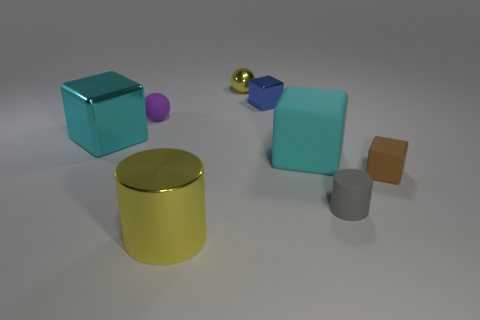Is there any other thing of the same color as the metallic cylinder?
Ensure brevity in your answer.  Yes. There is a big object that is in front of the gray cylinder; is it the same color as the small shiny ball?
Ensure brevity in your answer.  Yes. There is a cylinder that is to the right of the small block behind the large cyan block right of the yellow metal sphere; what is it made of?
Make the answer very short. Rubber. There is a tiny sphere that is the same color as the large cylinder; what material is it?
Your response must be concise. Metal. What number of large yellow cylinders are made of the same material as the brown block?
Ensure brevity in your answer.  0. Do the yellow object in front of the brown matte cube and the cyan metal block have the same size?
Your answer should be compact. Yes. There is a big block that is made of the same material as the small gray cylinder; what color is it?
Give a very brief answer. Cyan. There is a tiny gray object; how many tiny blue cubes are behind it?
Keep it short and to the point. 1. Does the large cylinder left of the tiny yellow metallic ball have the same color as the sphere that is on the right side of the matte sphere?
Your answer should be compact. Yes. What is the color of the other thing that is the same shape as the tiny gray object?
Make the answer very short. Yellow. 